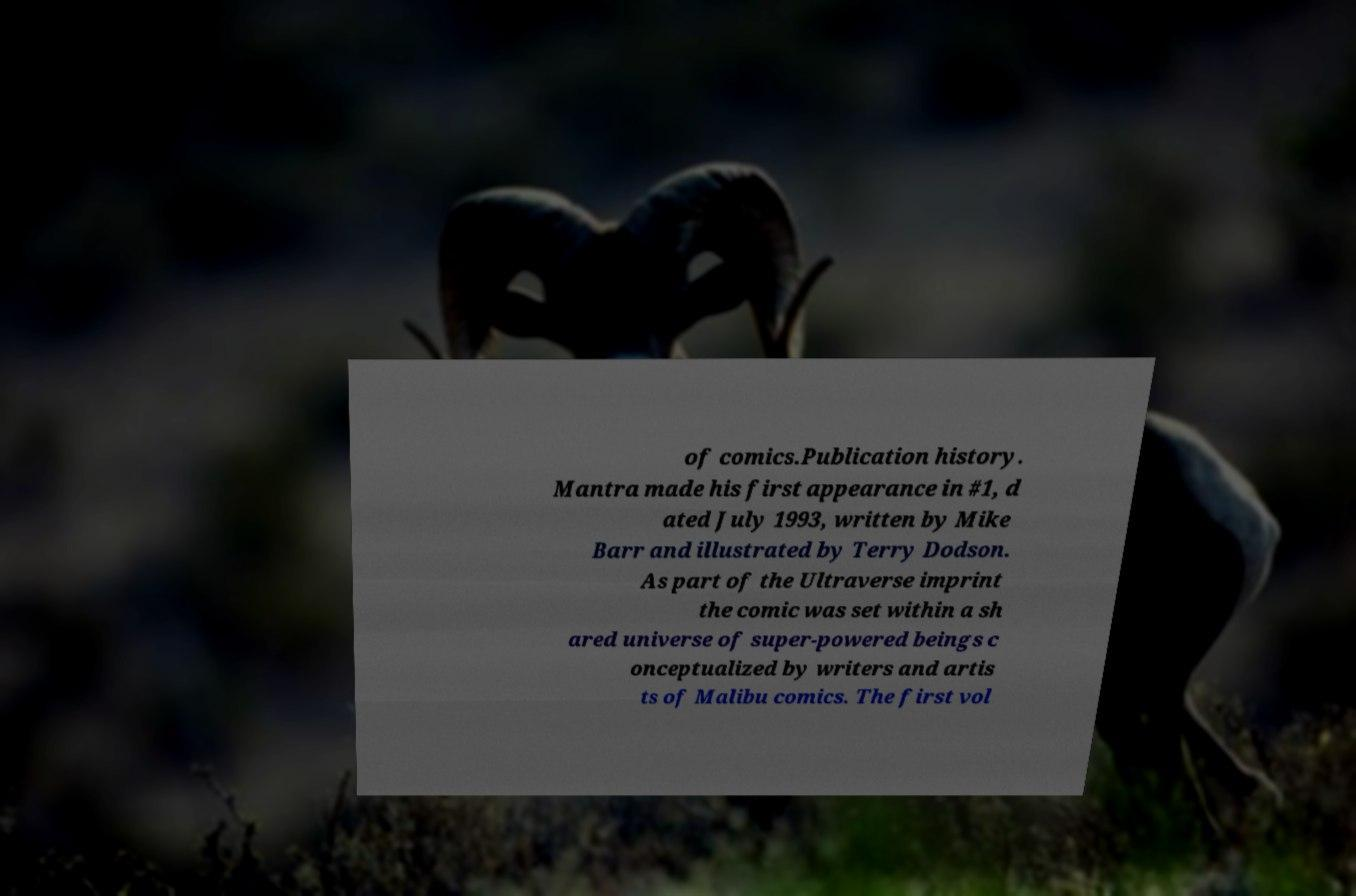Please identify and transcribe the text found in this image. of comics.Publication history. Mantra made his first appearance in #1, d ated July 1993, written by Mike Barr and illustrated by Terry Dodson. As part of the Ultraverse imprint the comic was set within a sh ared universe of super-powered beings c onceptualized by writers and artis ts of Malibu comics. The first vol 